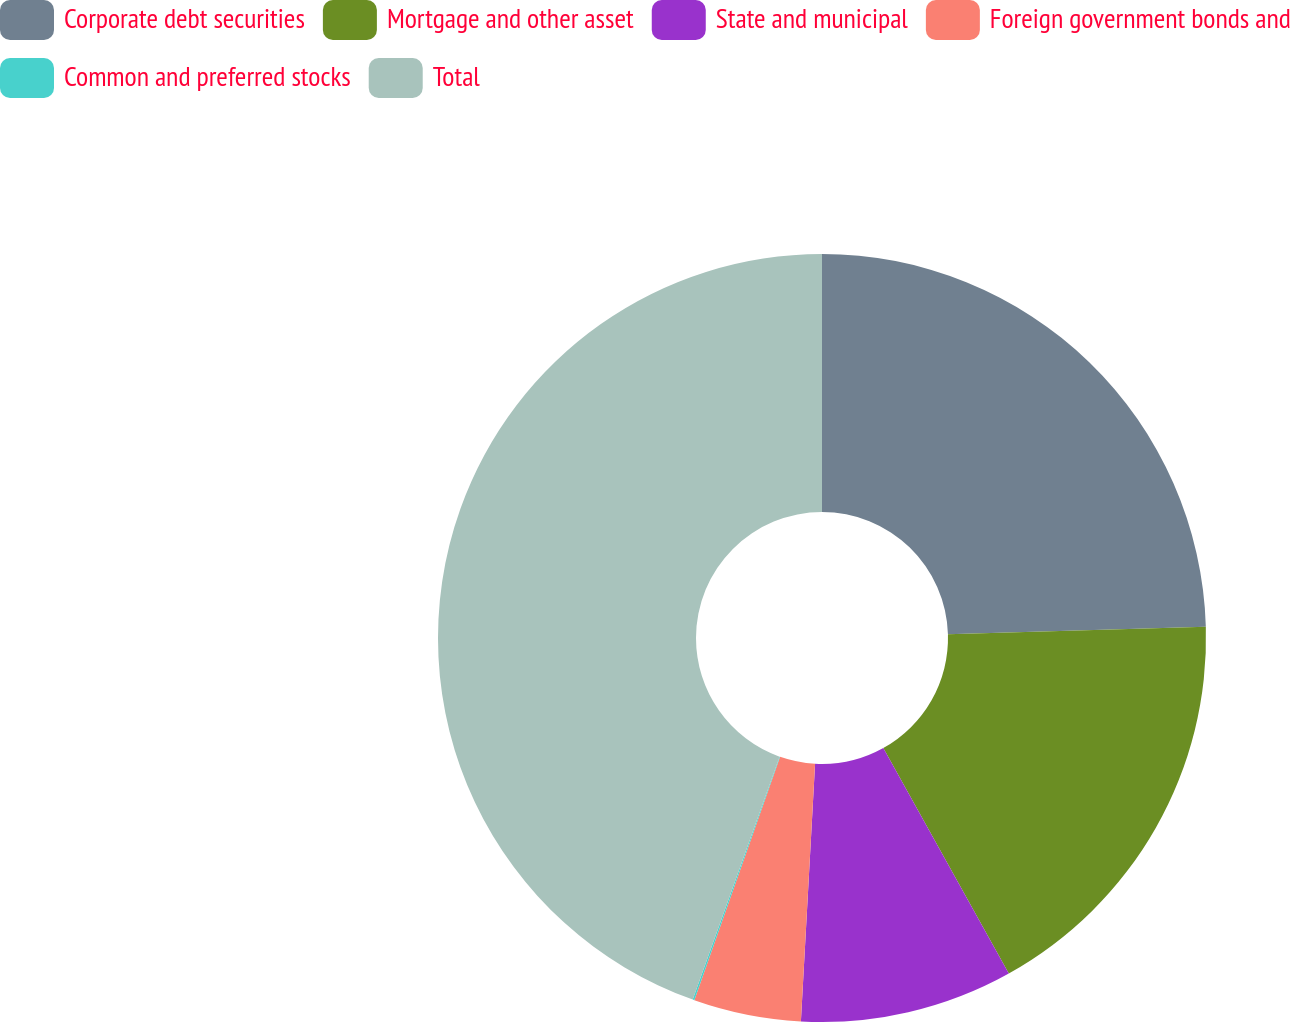Convert chart. <chart><loc_0><loc_0><loc_500><loc_500><pie_chart><fcel>Corporate debt securities<fcel>Mortgage and other asset<fcel>State and municipal<fcel>Foreign government bonds and<fcel>Common and preferred stocks<fcel>Total<nl><fcel>24.53%<fcel>17.38%<fcel>8.96%<fcel>4.52%<fcel>0.07%<fcel>44.53%<nl></chart> 